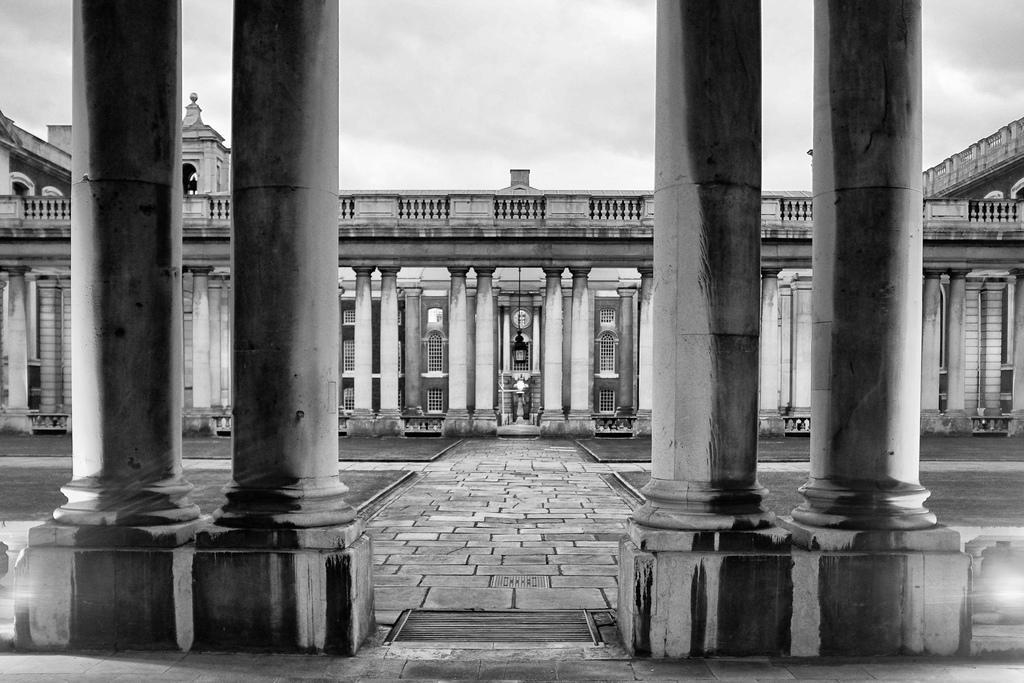Please provide a concise description of this image. This is a black and white picture, in the front there are pillars on either side with a building behind it, in the middle there is garden and above its sky. 